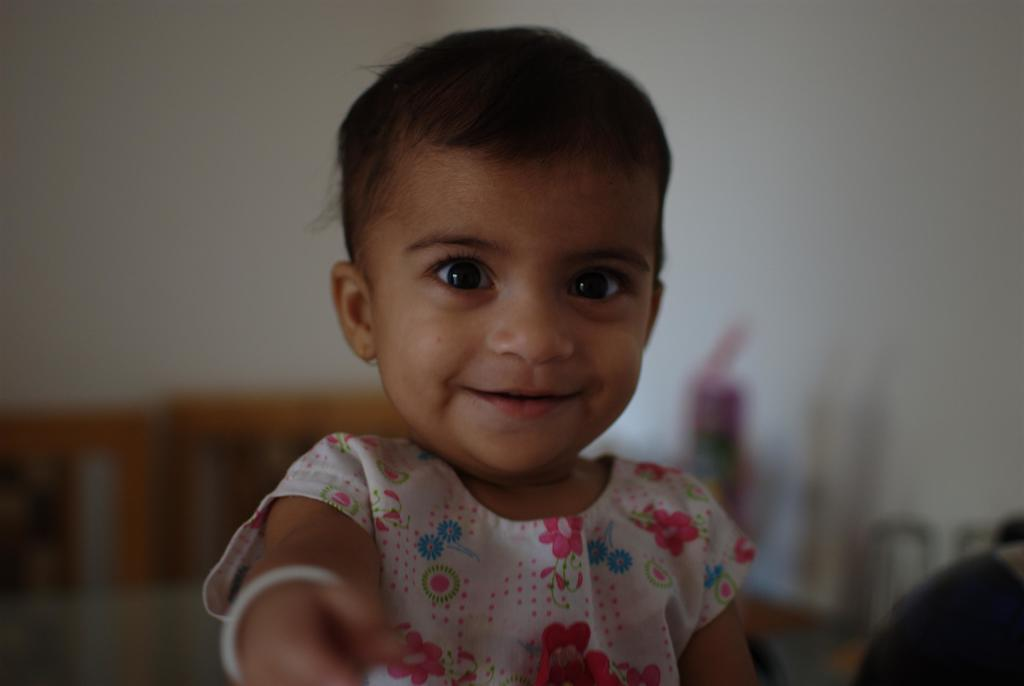What is the main subject of the image? There is a baby girl in the image. What is the baby girl doing in the image? The baby girl is smiling. How would you describe the background of the image? The background of the image appears blurry. What type of crack can be seen on the basketball in the image? There is no basketball or crack present in the image; it features a baby girl smiling. 